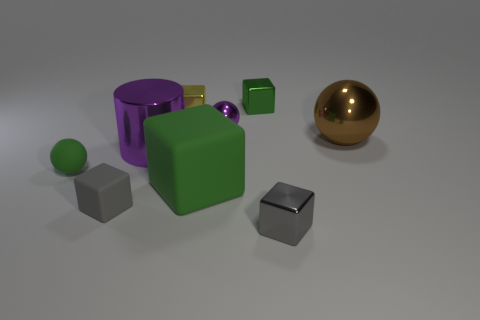What is the size of the rubber cube that is the same color as the matte sphere?
Ensure brevity in your answer.  Large. Is the color of the metal object that is in front of the small green matte sphere the same as the matte cube that is to the left of the large metal cylinder?
Offer a very short reply. Yes. How many matte objects are the same size as the purple shiny cylinder?
Offer a very short reply. 1. Is the number of large objects on the left side of the gray metal object the same as the number of small blocks that are behind the small matte cube?
Provide a short and direct response. Yes. Are the large cylinder and the tiny green ball made of the same material?
Keep it short and to the point. No. There is a large object left of the big block; are there any big things in front of it?
Provide a short and direct response. Yes. Are there any large green rubber things that have the same shape as the tiny gray rubber thing?
Give a very brief answer. Yes. Is the color of the large block the same as the tiny matte ball?
Your response must be concise. Yes. The gray thing that is right of the tiny gray object on the left side of the tiny purple metallic sphere is made of what material?
Offer a very short reply. Metal. The gray metal thing has what size?
Your answer should be compact. Small. 